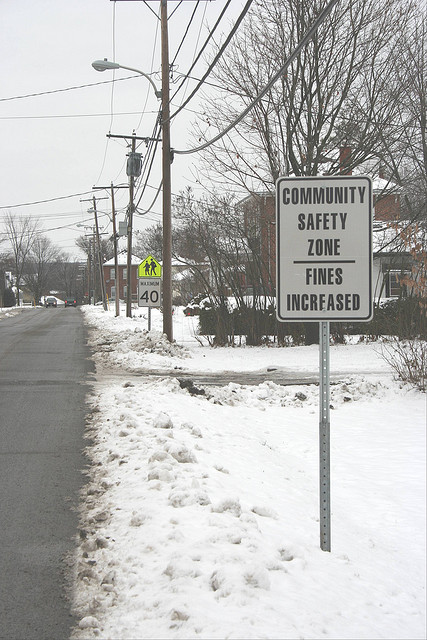<image>What does the numbers on the floor represent? It is unclear what the numbers on the floor represent. It could be speed, miles, speed limit or parking spaces. What does the numbers on the floor represent? I am not sure what the numbers on the floor represent. It can be related to speed, speed limit or parking spaces. 